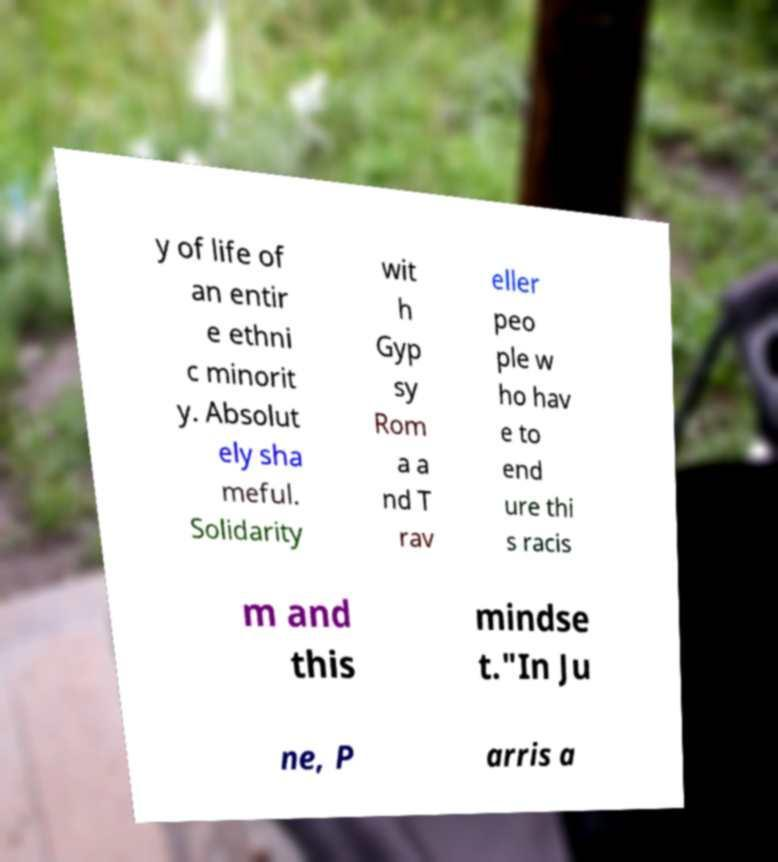What messages or text are displayed in this image? I need them in a readable, typed format. y of life of an entir e ethni c minorit y. Absolut ely sha meful. Solidarity wit h Gyp sy Rom a a nd T rav eller peo ple w ho hav e to end ure thi s racis m and this mindse t."In Ju ne, P arris a 